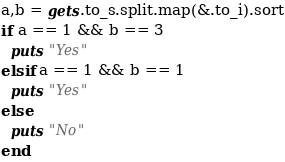Convert code to text. <code><loc_0><loc_0><loc_500><loc_500><_Crystal_>a,b = gets.to_s.split.map(&.to_i).sort
if a == 1 && b == 3
  puts "Yes"
elsif a == 1 && b == 1
  puts "Yes"
else
  puts "No"
end</code> 